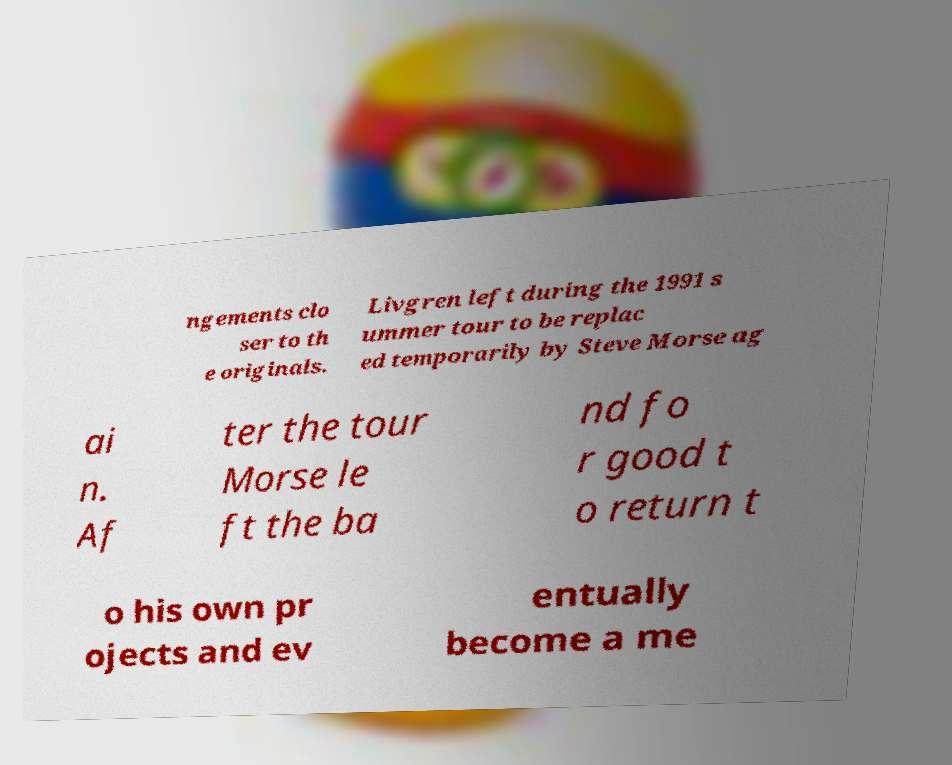There's text embedded in this image that I need extracted. Can you transcribe it verbatim? ngements clo ser to th e originals. Livgren left during the 1991 s ummer tour to be replac ed temporarily by Steve Morse ag ai n. Af ter the tour Morse le ft the ba nd fo r good t o return t o his own pr ojects and ev entually become a me 